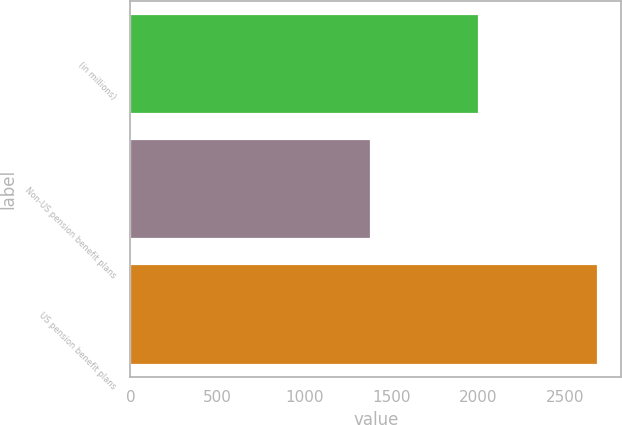Convert chart to OTSL. <chart><loc_0><loc_0><loc_500><loc_500><bar_chart><fcel>(in millions)<fcel>Non-US pension benefit plans<fcel>US pension benefit plans<nl><fcel>2006<fcel>1384<fcel>2689<nl></chart> 